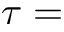Convert formula to latex. <formula><loc_0><loc_0><loc_500><loc_500>\tau =</formula> 